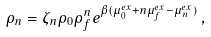<formula> <loc_0><loc_0><loc_500><loc_500>\rho _ { n } = \zeta _ { n } \rho _ { 0 } \rho _ { f } ^ { n } e ^ { \beta ( \mu _ { 0 } ^ { e x } + n \mu _ { f } ^ { e x } - \mu _ { n } ^ { e x } ) } \, ,</formula> 